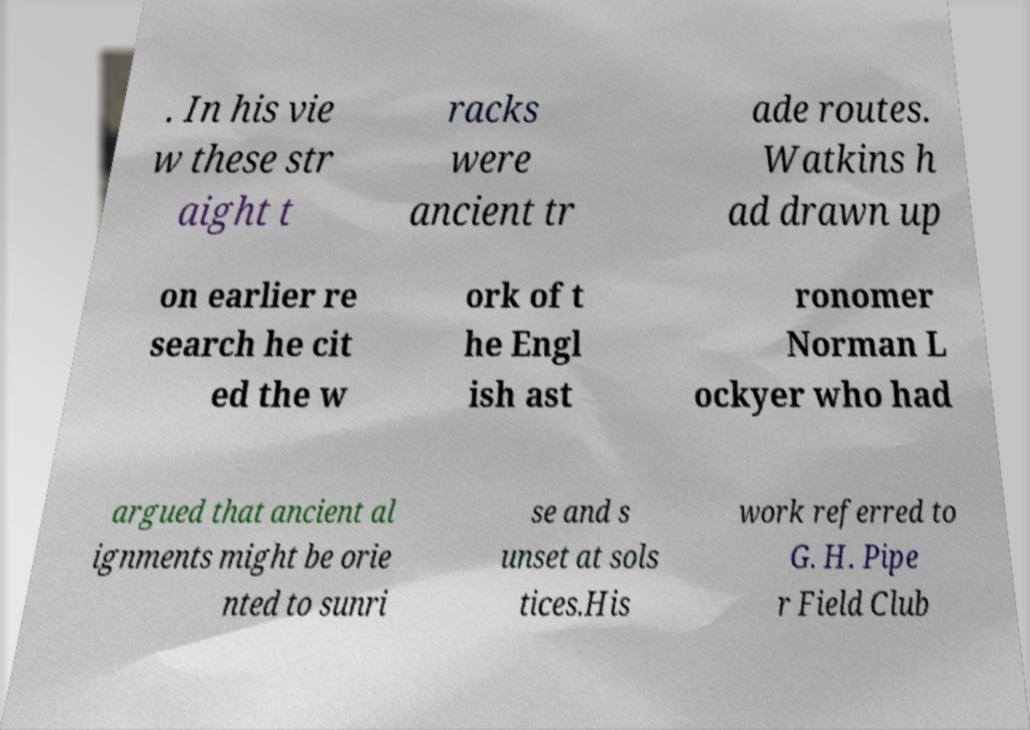Could you assist in decoding the text presented in this image and type it out clearly? . In his vie w these str aight t racks were ancient tr ade routes. Watkins h ad drawn up on earlier re search he cit ed the w ork of t he Engl ish ast ronomer Norman L ockyer who had argued that ancient al ignments might be orie nted to sunri se and s unset at sols tices.His work referred to G. H. Pipe r Field Club 